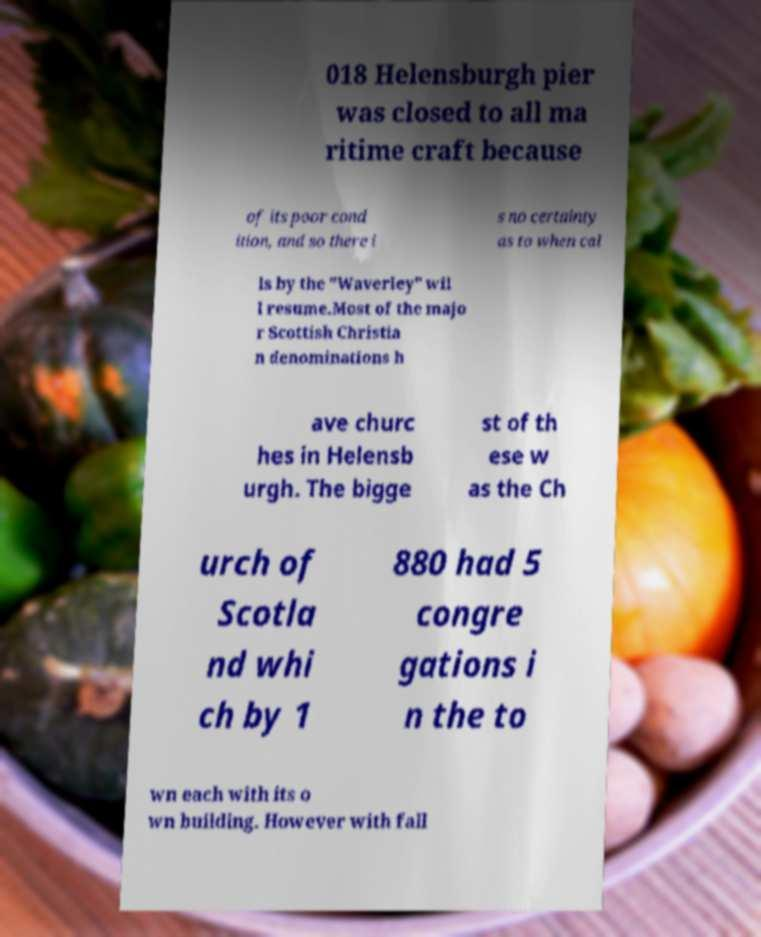There's text embedded in this image that I need extracted. Can you transcribe it verbatim? 018 Helensburgh pier was closed to all ma ritime craft because of its poor cond ition, and so there i s no certainty as to when cal ls by the "Waverley" wil l resume.Most of the majo r Scottish Christia n denominations h ave churc hes in Helensb urgh. The bigge st of th ese w as the Ch urch of Scotla nd whi ch by 1 880 had 5 congre gations i n the to wn each with its o wn building. However with fall 